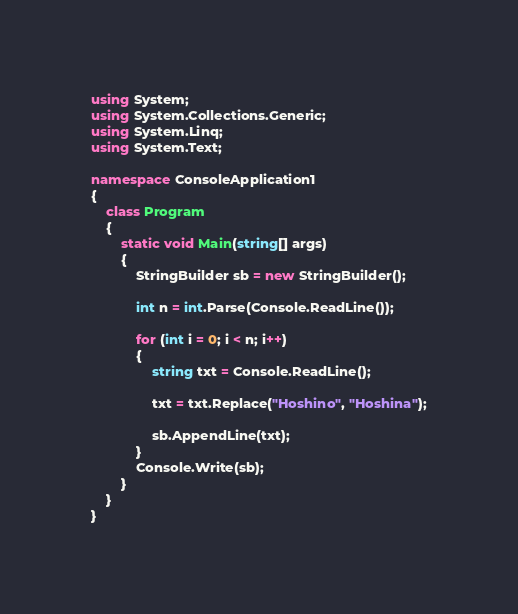Convert code to text. <code><loc_0><loc_0><loc_500><loc_500><_C#_>using System;
using System.Collections.Generic;
using System.Linq;
using System.Text;

namespace ConsoleApplication1
{
    class Program
    {
        static void Main(string[] args)
        {
            StringBuilder sb = new StringBuilder();

            int n = int.Parse(Console.ReadLine());

            for (int i = 0; i < n; i++)
            {
                string txt = Console.ReadLine();

                txt = txt.Replace("Hoshino", "Hoshina");

                sb.AppendLine(txt);
            }
            Console.Write(sb);
        }
    }
}</code> 